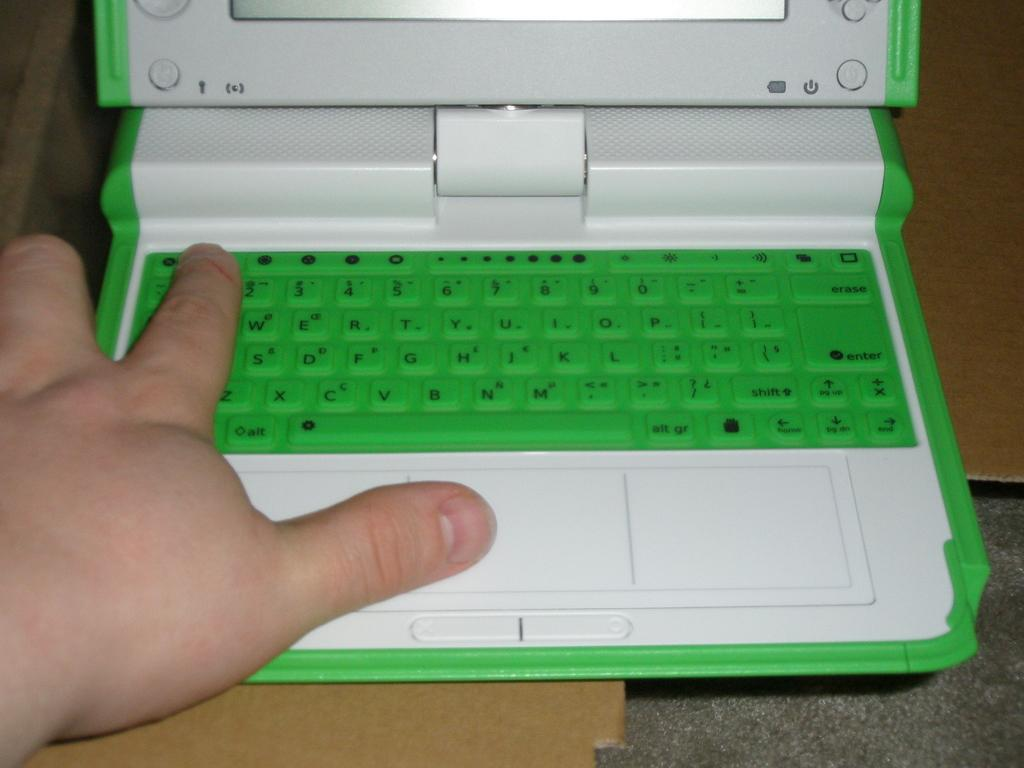Provide a one-sentence caption for the provided image. The up and down buttons on the green keyboard are located below the enter button. 